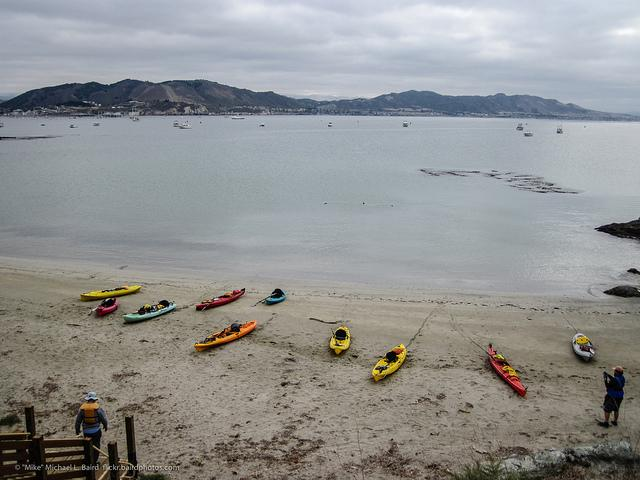What method do these vessels shown here normally gain movement?

Choices:
A) motors
B) wind
C) none
D) oars oars 